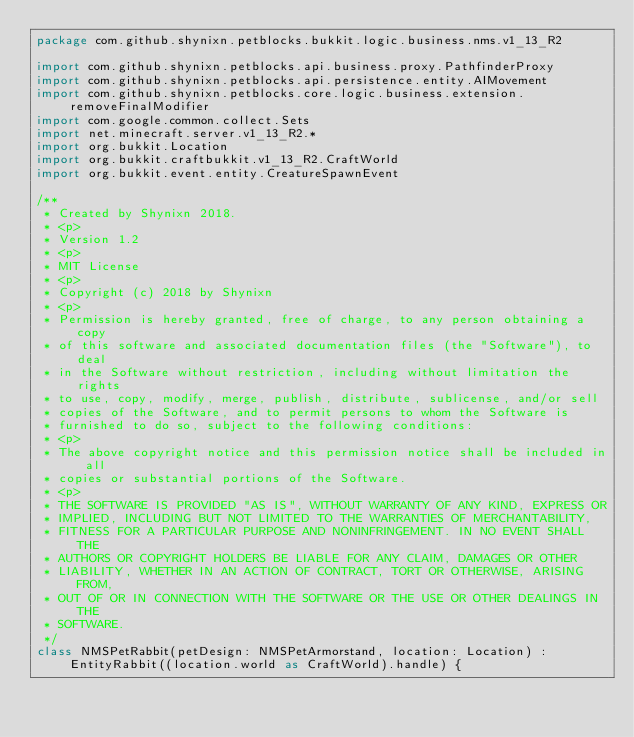<code> <loc_0><loc_0><loc_500><loc_500><_Kotlin_>package com.github.shynixn.petblocks.bukkit.logic.business.nms.v1_13_R2

import com.github.shynixn.petblocks.api.business.proxy.PathfinderProxy
import com.github.shynixn.petblocks.api.persistence.entity.AIMovement
import com.github.shynixn.petblocks.core.logic.business.extension.removeFinalModifier
import com.google.common.collect.Sets
import net.minecraft.server.v1_13_R2.*
import org.bukkit.Location
import org.bukkit.craftbukkit.v1_13_R2.CraftWorld
import org.bukkit.event.entity.CreatureSpawnEvent

/**
 * Created by Shynixn 2018.
 * <p>
 * Version 1.2
 * <p>
 * MIT License
 * <p>
 * Copyright (c) 2018 by Shynixn
 * <p>
 * Permission is hereby granted, free of charge, to any person obtaining a copy
 * of this software and associated documentation files (the "Software"), to deal
 * in the Software without restriction, including without limitation the rights
 * to use, copy, modify, merge, publish, distribute, sublicense, and/or sell
 * copies of the Software, and to permit persons to whom the Software is
 * furnished to do so, subject to the following conditions:
 * <p>
 * The above copyright notice and this permission notice shall be included in all
 * copies or substantial portions of the Software.
 * <p>
 * THE SOFTWARE IS PROVIDED "AS IS", WITHOUT WARRANTY OF ANY KIND, EXPRESS OR
 * IMPLIED, INCLUDING BUT NOT LIMITED TO THE WARRANTIES OF MERCHANTABILITY,
 * FITNESS FOR A PARTICULAR PURPOSE AND NONINFRINGEMENT. IN NO EVENT SHALL THE
 * AUTHORS OR COPYRIGHT HOLDERS BE LIABLE FOR ANY CLAIM, DAMAGES OR OTHER
 * LIABILITY, WHETHER IN AN ACTION OF CONTRACT, TORT OR OTHERWISE, ARISING FROM,
 * OUT OF OR IN CONNECTION WITH THE SOFTWARE OR THE USE OR OTHER DEALINGS IN THE
 * SOFTWARE.
 */
class NMSPetRabbit(petDesign: NMSPetArmorstand, location: Location) : EntityRabbit((location.world as CraftWorld).handle) {</code> 